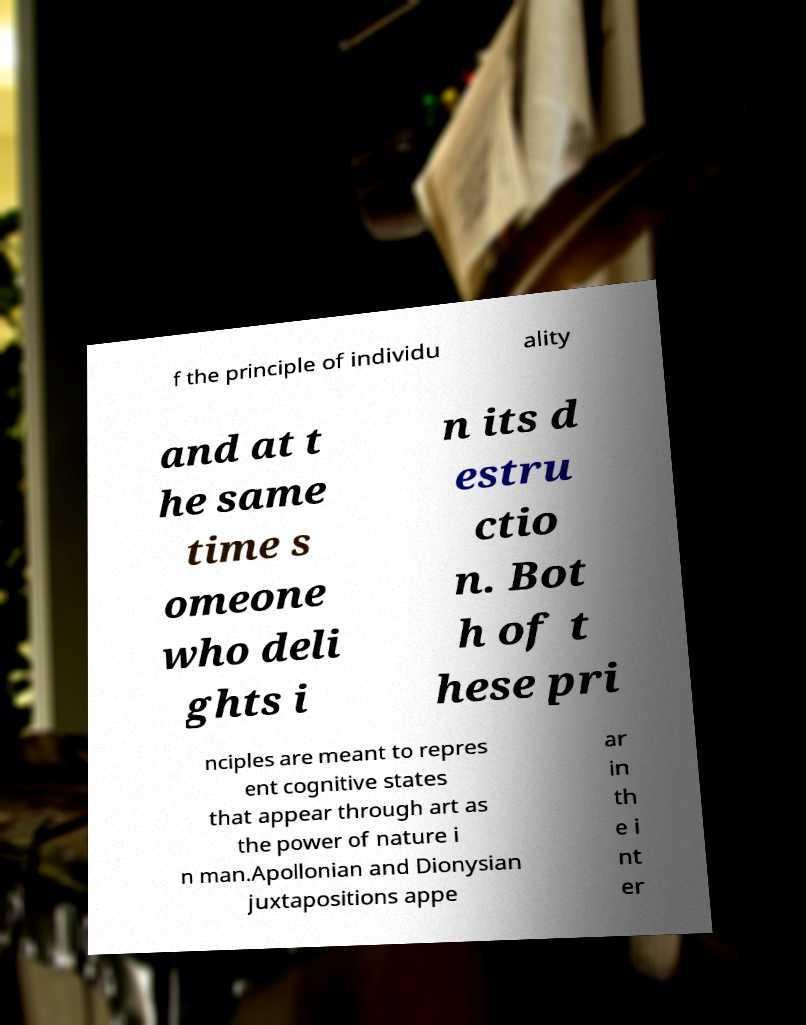Please identify and transcribe the text found in this image. f the principle of individu ality and at t he same time s omeone who deli ghts i n its d estru ctio n. Bot h of t hese pri nciples are meant to repres ent cognitive states that appear through art as the power of nature i n man.Apollonian and Dionysian juxtapositions appe ar in th e i nt er 